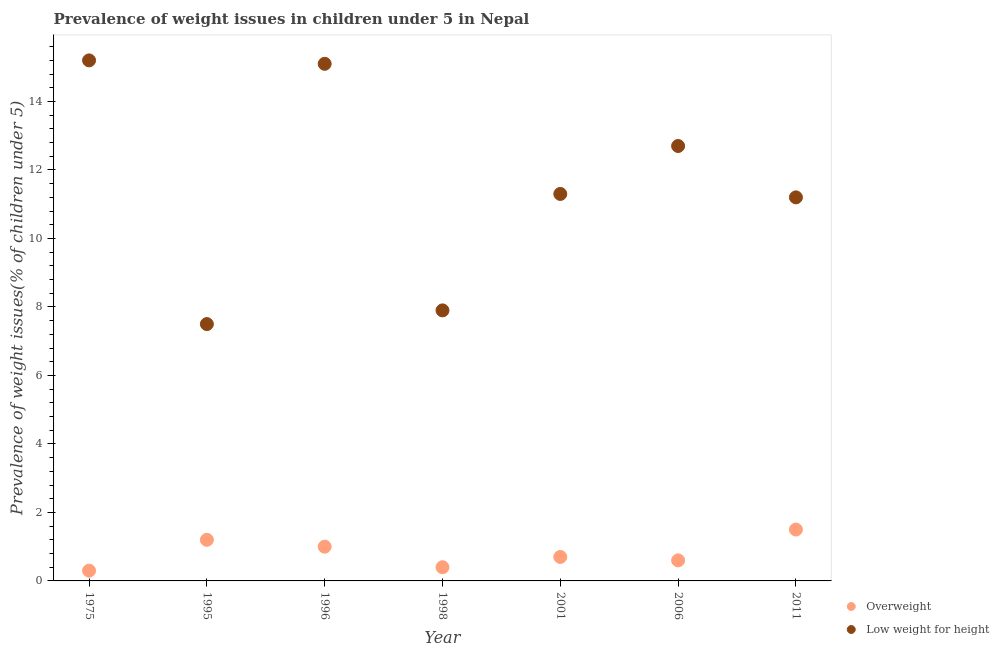How many different coloured dotlines are there?
Make the answer very short. 2. Is the number of dotlines equal to the number of legend labels?
Ensure brevity in your answer.  Yes. Across all years, what is the maximum percentage of underweight children?
Provide a succinct answer. 15.2. In which year was the percentage of underweight children maximum?
Ensure brevity in your answer.  1975. In which year was the percentage of overweight children minimum?
Offer a very short reply. 1975. What is the total percentage of underweight children in the graph?
Your answer should be compact. 80.9. What is the difference between the percentage of overweight children in 1996 and that in 2006?
Give a very brief answer. 0.4. What is the difference between the percentage of underweight children in 1998 and the percentage of overweight children in 1996?
Your response must be concise. 6.9. What is the average percentage of underweight children per year?
Offer a very short reply. 11.56. In the year 1995, what is the difference between the percentage of overweight children and percentage of underweight children?
Keep it short and to the point. -6.3. In how many years, is the percentage of overweight children greater than 0.4 %?
Provide a short and direct response. 6. What is the ratio of the percentage of underweight children in 1996 to that in 2006?
Your answer should be very brief. 1.19. Is the percentage of underweight children in 1995 less than that in 1998?
Keep it short and to the point. Yes. What is the difference between the highest and the second highest percentage of overweight children?
Your answer should be compact. 0.3. What is the difference between the highest and the lowest percentage of overweight children?
Ensure brevity in your answer.  1.2. Is the sum of the percentage of underweight children in 2001 and 2011 greater than the maximum percentage of overweight children across all years?
Your answer should be compact. Yes. Is the percentage of overweight children strictly less than the percentage of underweight children over the years?
Make the answer very short. Yes. How many dotlines are there?
Your answer should be compact. 2. How many years are there in the graph?
Provide a succinct answer. 7. What is the difference between two consecutive major ticks on the Y-axis?
Give a very brief answer. 2. Does the graph contain any zero values?
Your answer should be very brief. No. Where does the legend appear in the graph?
Your answer should be very brief. Bottom right. How many legend labels are there?
Offer a very short reply. 2. How are the legend labels stacked?
Ensure brevity in your answer.  Vertical. What is the title of the graph?
Provide a short and direct response. Prevalence of weight issues in children under 5 in Nepal. What is the label or title of the Y-axis?
Your answer should be very brief. Prevalence of weight issues(% of children under 5). What is the Prevalence of weight issues(% of children under 5) of Overweight in 1975?
Give a very brief answer. 0.3. What is the Prevalence of weight issues(% of children under 5) of Low weight for height in 1975?
Your answer should be very brief. 15.2. What is the Prevalence of weight issues(% of children under 5) of Overweight in 1995?
Provide a succinct answer. 1.2. What is the Prevalence of weight issues(% of children under 5) of Low weight for height in 1995?
Your answer should be compact. 7.5. What is the Prevalence of weight issues(% of children under 5) of Low weight for height in 1996?
Provide a short and direct response. 15.1. What is the Prevalence of weight issues(% of children under 5) in Overweight in 1998?
Make the answer very short. 0.4. What is the Prevalence of weight issues(% of children under 5) in Low weight for height in 1998?
Provide a short and direct response. 7.9. What is the Prevalence of weight issues(% of children under 5) of Overweight in 2001?
Make the answer very short. 0.7. What is the Prevalence of weight issues(% of children under 5) of Low weight for height in 2001?
Provide a succinct answer. 11.3. What is the Prevalence of weight issues(% of children under 5) in Overweight in 2006?
Provide a short and direct response. 0.6. What is the Prevalence of weight issues(% of children under 5) of Low weight for height in 2006?
Provide a short and direct response. 12.7. What is the Prevalence of weight issues(% of children under 5) of Overweight in 2011?
Make the answer very short. 1.5. What is the Prevalence of weight issues(% of children under 5) of Low weight for height in 2011?
Keep it short and to the point. 11.2. Across all years, what is the maximum Prevalence of weight issues(% of children under 5) in Overweight?
Ensure brevity in your answer.  1.5. Across all years, what is the maximum Prevalence of weight issues(% of children under 5) in Low weight for height?
Your response must be concise. 15.2. Across all years, what is the minimum Prevalence of weight issues(% of children under 5) in Overweight?
Give a very brief answer. 0.3. Across all years, what is the minimum Prevalence of weight issues(% of children under 5) in Low weight for height?
Provide a succinct answer. 7.5. What is the total Prevalence of weight issues(% of children under 5) in Low weight for height in the graph?
Make the answer very short. 80.9. What is the difference between the Prevalence of weight issues(% of children under 5) in Overweight in 1975 and that in 1995?
Keep it short and to the point. -0.9. What is the difference between the Prevalence of weight issues(% of children under 5) of Low weight for height in 1975 and that in 1995?
Provide a short and direct response. 7.7. What is the difference between the Prevalence of weight issues(% of children under 5) of Overweight in 1975 and that in 1996?
Provide a short and direct response. -0.7. What is the difference between the Prevalence of weight issues(% of children under 5) of Low weight for height in 1975 and that in 1996?
Offer a very short reply. 0.1. What is the difference between the Prevalence of weight issues(% of children under 5) of Low weight for height in 1975 and that in 2001?
Your response must be concise. 3.9. What is the difference between the Prevalence of weight issues(% of children under 5) of Overweight in 1975 and that in 2011?
Make the answer very short. -1.2. What is the difference between the Prevalence of weight issues(% of children under 5) of Low weight for height in 1975 and that in 2011?
Your response must be concise. 4. What is the difference between the Prevalence of weight issues(% of children under 5) in Low weight for height in 1995 and that in 1996?
Offer a very short reply. -7.6. What is the difference between the Prevalence of weight issues(% of children under 5) of Overweight in 1995 and that in 2006?
Your response must be concise. 0.6. What is the difference between the Prevalence of weight issues(% of children under 5) in Overweight in 1995 and that in 2011?
Your answer should be very brief. -0.3. What is the difference between the Prevalence of weight issues(% of children under 5) of Low weight for height in 1996 and that in 2001?
Make the answer very short. 3.8. What is the difference between the Prevalence of weight issues(% of children under 5) of Overweight in 1998 and that in 2001?
Your response must be concise. -0.3. What is the difference between the Prevalence of weight issues(% of children under 5) of Overweight in 1998 and that in 2006?
Offer a very short reply. -0.2. What is the difference between the Prevalence of weight issues(% of children under 5) of Low weight for height in 1998 and that in 2006?
Give a very brief answer. -4.8. What is the difference between the Prevalence of weight issues(% of children under 5) of Overweight in 1998 and that in 2011?
Keep it short and to the point. -1.1. What is the difference between the Prevalence of weight issues(% of children under 5) of Overweight in 2001 and that in 2006?
Provide a short and direct response. 0.1. What is the difference between the Prevalence of weight issues(% of children under 5) in Overweight in 2001 and that in 2011?
Provide a succinct answer. -0.8. What is the difference between the Prevalence of weight issues(% of children under 5) in Low weight for height in 2001 and that in 2011?
Ensure brevity in your answer.  0.1. What is the difference between the Prevalence of weight issues(% of children under 5) of Overweight in 2006 and that in 2011?
Your response must be concise. -0.9. What is the difference between the Prevalence of weight issues(% of children under 5) of Overweight in 1975 and the Prevalence of weight issues(% of children under 5) of Low weight for height in 1996?
Ensure brevity in your answer.  -14.8. What is the difference between the Prevalence of weight issues(% of children under 5) of Overweight in 1975 and the Prevalence of weight issues(% of children under 5) of Low weight for height in 2001?
Your response must be concise. -11. What is the difference between the Prevalence of weight issues(% of children under 5) in Overweight in 1975 and the Prevalence of weight issues(% of children under 5) in Low weight for height in 2006?
Keep it short and to the point. -12.4. What is the difference between the Prevalence of weight issues(% of children under 5) of Overweight in 1995 and the Prevalence of weight issues(% of children under 5) of Low weight for height in 1996?
Give a very brief answer. -13.9. What is the difference between the Prevalence of weight issues(% of children under 5) in Overweight in 1995 and the Prevalence of weight issues(% of children under 5) in Low weight for height in 1998?
Give a very brief answer. -6.7. What is the difference between the Prevalence of weight issues(% of children under 5) in Overweight in 1995 and the Prevalence of weight issues(% of children under 5) in Low weight for height in 2006?
Provide a succinct answer. -11.5. What is the difference between the Prevalence of weight issues(% of children under 5) of Overweight in 1996 and the Prevalence of weight issues(% of children under 5) of Low weight for height in 1998?
Keep it short and to the point. -6.9. What is the difference between the Prevalence of weight issues(% of children under 5) of Overweight in 1996 and the Prevalence of weight issues(% of children under 5) of Low weight for height in 2001?
Offer a terse response. -10.3. What is the difference between the Prevalence of weight issues(% of children under 5) of Overweight in 1998 and the Prevalence of weight issues(% of children under 5) of Low weight for height in 2001?
Your answer should be very brief. -10.9. What is the difference between the Prevalence of weight issues(% of children under 5) of Overweight in 1998 and the Prevalence of weight issues(% of children under 5) of Low weight for height in 2011?
Give a very brief answer. -10.8. What is the difference between the Prevalence of weight issues(% of children under 5) of Overweight in 2001 and the Prevalence of weight issues(% of children under 5) of Low weight for height in 2006?
Provide a succinct answer. -12. What is the difference between the Prevalence of weight issues(% of children under 5) in Overweight in 2001 and the Prevalence of weight issues(% of children under 5) in Low weight for height in 2011?
Your response must be concise. -10.5. What is the difference between the Prevalence of weight issues(% of children under 5) of Overweight in 2006 and the Prevalence of weight issues(% of children under 5) of Low weight for height in 2011?
Your response must be concise. -10.6. What is the average Prevalence of weight issues(% of children under 5) in Overweight per year?
Make the answer very short. 0.81. What is the average Prevalence of weight issues(% of children under 5) of Low weight for height per year?
Your answer should be compact. 11.56. In the year 1975, what is the difference between the Prevalence of weight issues(% of children under 5) of Overweight and Prevalence of weight issues(% of children under 5) of Low weight for height?
Your answer should be very brief. -14.9. In the year 1996, what is the difference between the Prevalence of weight issues(% of children under 5) in Overweight and Prevalence of weight issues(% of children under 5) in Low weight for height?
Your answer should be compact. -14.1. In the year 2001, what is the difference between the Prevalence of weight issues(% of children under 5) in Overweight and Prevalence of weight issues(% of children under 5) in Low weight for height?
Offer a terse response. -10.6. In the year 2006, what is the difference between the Prevalence of weight issues(% of children under 5) in Overweight and Prevalence of weight issues(% of children under 5) in Low weight for height?
Give a very brief answer. -12.1. What is the ratio of the Prevalence of weight issues(% of children under 5) in Overweight in 1975 to that in 1995?
Give a very brief answer. 0.25. What is the ratio of the Prevalence of weight issues(% of children under 5) of Low weight for height in 1975 to that in 1995?
Your answer should be very brief. 2.03. What is the ratio of the Prevalence of weight issues(% of children under 5) of Overweight in 1975 to that in 1996?
Your answer should be very brief. 0.3. What is the ratio of the Prevalence of weight issues(% of children under 5) of Low weight for height in 1975 to that in 1996?
Your answer should be compact. 1.01. What is the ratio of the Prevalence of weight issues(% of children under 5) in Low weight for height in 1975 to that in 1998?
Your answer should be very brief. 1.92. What is the ratio of the Prevalence of weight issues(% of children under 5) in Overweight in 1975 to that in 2001?
Offer a very short reply. 0.43. What is the ratio of the Prevalence of weight issues(% of children under 5) in Low weight for height in 1975 to that in 2001?
Your answer should be very brief. 1.35. What is the ratio of the Prevalence of weight issues(% of children under 5) in Overweight in 1975 to that in 2006?
Your response must be concise. 0.5. What is the ratio of the Prevalence of weight issues(% of children under 5) of Low weight for height in 1975 to that in 2006?
Provide a short and direct response. 1.2. What is the ratio of the Prevalence of weight issues(% of children under 5) of Overweight in 1975 to that in 2011?
Offer a terse response. 0.2. What is the ratio of the Prevalence of weight issues(% of children under 5) in Low weight for height in 1975 to that in 2011?
Offer a very short reply. 1.36. What is the ratio of the Prevalence of weight issues(% of children under 5) of Low weight for height in 1995 to that in 1996?
Your answer should be compact. 0.5. What is the ratio of the Prevalence of weight issues(% of children under 5) of Overweight in 1995 to that in 1998?
Make the answer very short. 3. What is the ratio of the Prevalence of weight issues(% of children under 5) in Low weight for height in 1995 to that in 1998?
Provide a short and direct response. 0.95. What is the ratio of the Prevalence of weight issues(% of children under 5) of Overweight in 1995 to that in 2001?
Provide a short and direct response. 1.71. What is the ratio of the Prevalence of weight issues(% of children under 5) in Low weight for height in 1995 to that in 2001?
Provide a succinct answer. 0.66. What is the ratio of the Prevalence of weight issues(% of children under 5) of Overweight in 1995 to that in 2006?
Ensure brevity in your answer.  2. What is the ratio of the Prevalence of weight issues(% of children under 5) in Low weight for height in 1995 to that in 2006?
Provide a short and direct response. 0.59. What is the ratio of the Prevalence of weight issues(% of children under 5) in Low weight for height in 1995 to that in 2011?
Your answer should be compact. 0.67. What is the ratio of the Prevalence of weight issues(% of children under 5) of Low weight for height in 1996 to that in 1998?
Make the answer very short. 1.91. What is the ratio of the Prevalence of weight issues(% of children under 5) of Overweight in 1996 to that in 2001?
Offer a terse response. 1.43. What is the ratio of the Prevalence of weight issues(% of children under 5) in Low weight for height in 1996 to that in 2001?
Make the answer very short. 1.34. What is the ratio of the Prevalence of weight issues(% of children under 5) in Low weight for height in 1996 to that in 2006?
Ensure brevity in your answer.  1.19. What is the ratio of the Prevalence of weight issues(% of children under 5) of Low weight for height in 1996 to that in 2011?
Your answer should be very brief. 1.35. What is the ratio of the Prevalence of weight issues(% of children under 5) of Overweight in 1998 to that in 2001?
Your answer should be very brief. 0.57. What is the ratio of the Prevalence of weight issues(% of children under 5) in Low weight for height in 1998 to that in 2001?
Make the answer very short. 0.7. What is the ratio of the Prevalence of weight issues(% of children under 5) of Low weight for height in 1998 to that in 2006?
Give a very brief answer. 0.62. What is the ratio of the Prevalence of weight issues(% of children under 5) of Overweight in 1998 to that in 2011?
Provide a short and direct response. 0.27. What is the ratio of the Prevalence of weight issues(% of children under 5) of Low weight for height in 1998 to that in 2011?
Offer a very short reply. 0.71. What is the ratio of the Prevalence of weight issues(% of children under 5) in Low weight for height in 2001 to that in 2006?
Keep it short and to the point. 0.89. What is the ratio of the Prevalence of weight issues(% of children under 5) in Overweight in 2001 to that in 2011?
Give a very brief answer. 0.47. What is the ratio of the Prevalence of weight issues(% of children under 5) in Low weight for height in 2001 to that in 2011?
Make the answer very short. 1.01. What is the ratio of the Prevalence of weight issues(% of children under 5) in Overweight in 2006 to that in 2011?
Your response must be concise. 0.4. What is the ratio of the Prevalence of weight issues(% of children under 5) of Low weight for height in 2006 to that in 2011?
Keep it short and to the point. 1.13. What is the difference between the highest and the second highest Prevalence of weight issues(% of children under 5) of Low weight for height?
Offer a terse response. 0.1. What is the difference between the highest and the lowest Prevalence of weight issues(% of children under 5) of Overweight?
Your answer should be very brief. 1.2. What is the difference between the highest and the lowest Prevalence of weight issues(% of children under 5) in Low weight for height?
Make the answer very short. 7.7. 